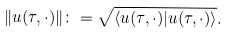<formula> <loc_0><loc_0><loc_500><loc_500>\| u ( \tau , \cdot ) \| \colon = \sqrt { \langle u ( \tau , \cdot ) | u ( \tau , \cdot ) \rangle } .</formula> 